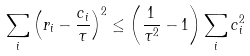Convert formula to latex. <formula><loc_0><loc_0><loc_500><loc_500>\sum _ { i } \left ( r _ { i } - \frac { c _ { i } } { \tau } \right ) ^ { 2 } \leq \left ( \frac { 1 } { \tau ^ { 2 } } - 1 \right ) \sum _ { i } c _ { i } ^ { 2 }</formula> 